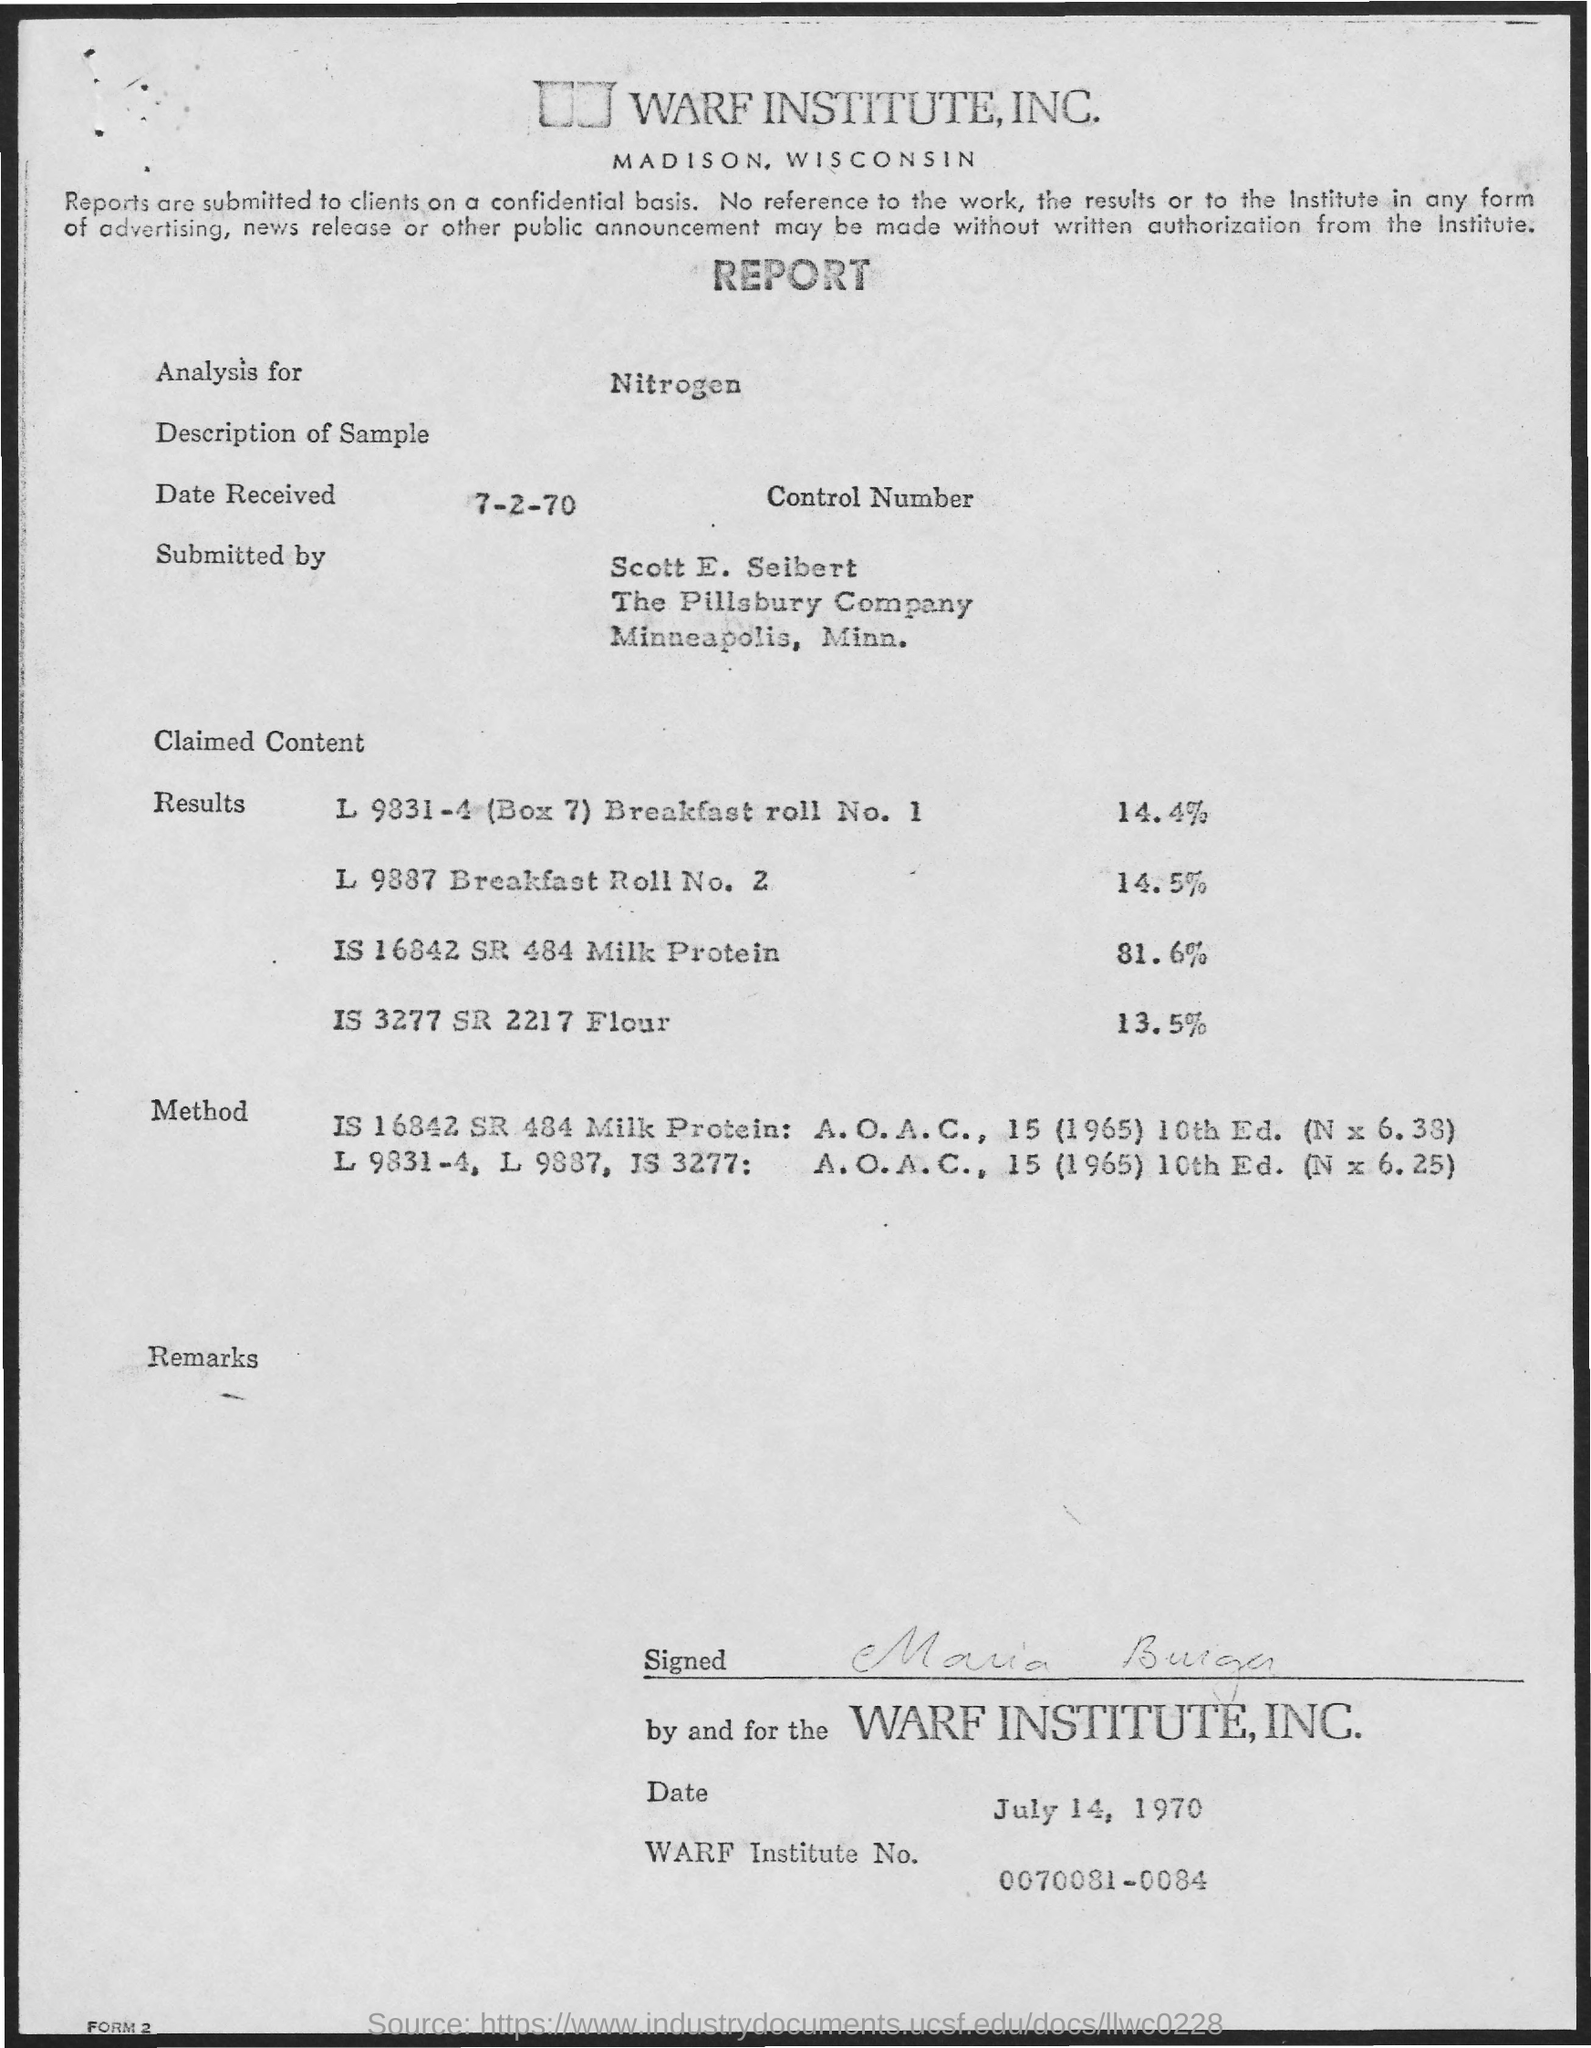What is the name of the institute?
Offer a terse response. Warf Institute. What is the Warf Institute No.?
Your response must be concise. 0070081-0084. What is the date Received?
Your response must be concise. 7-2-70. 